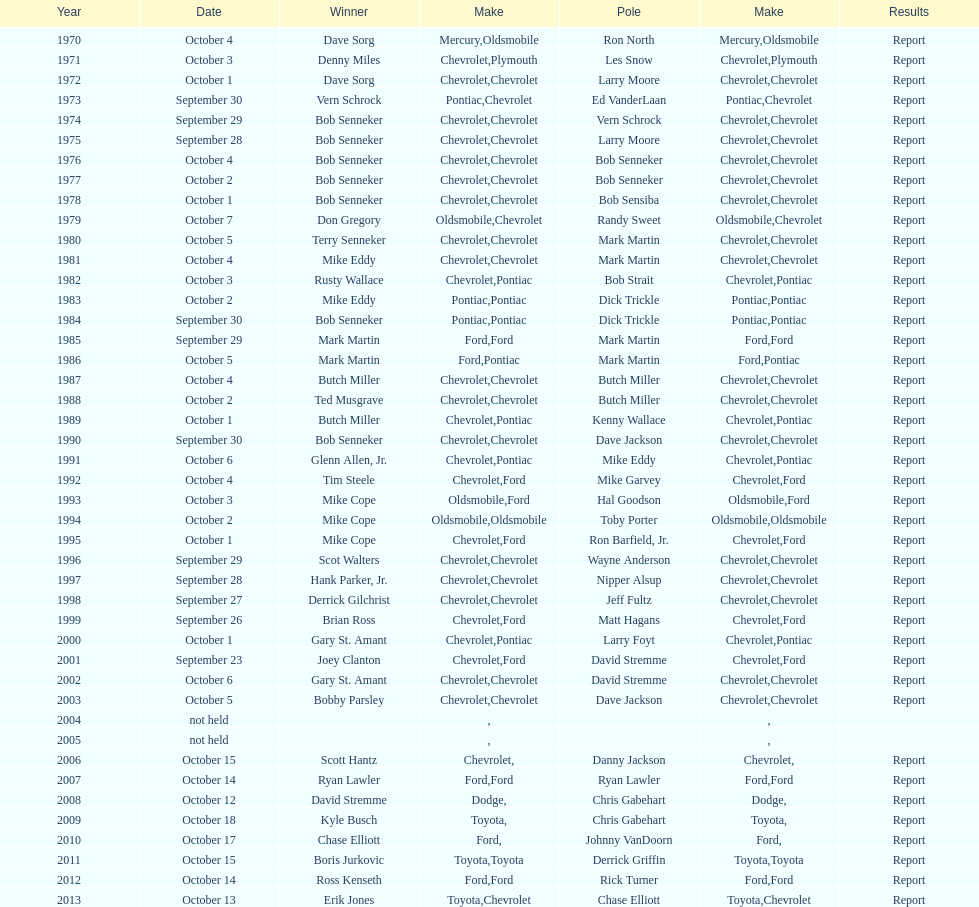How many winning oldsmobile vehicles made the list? 3. 